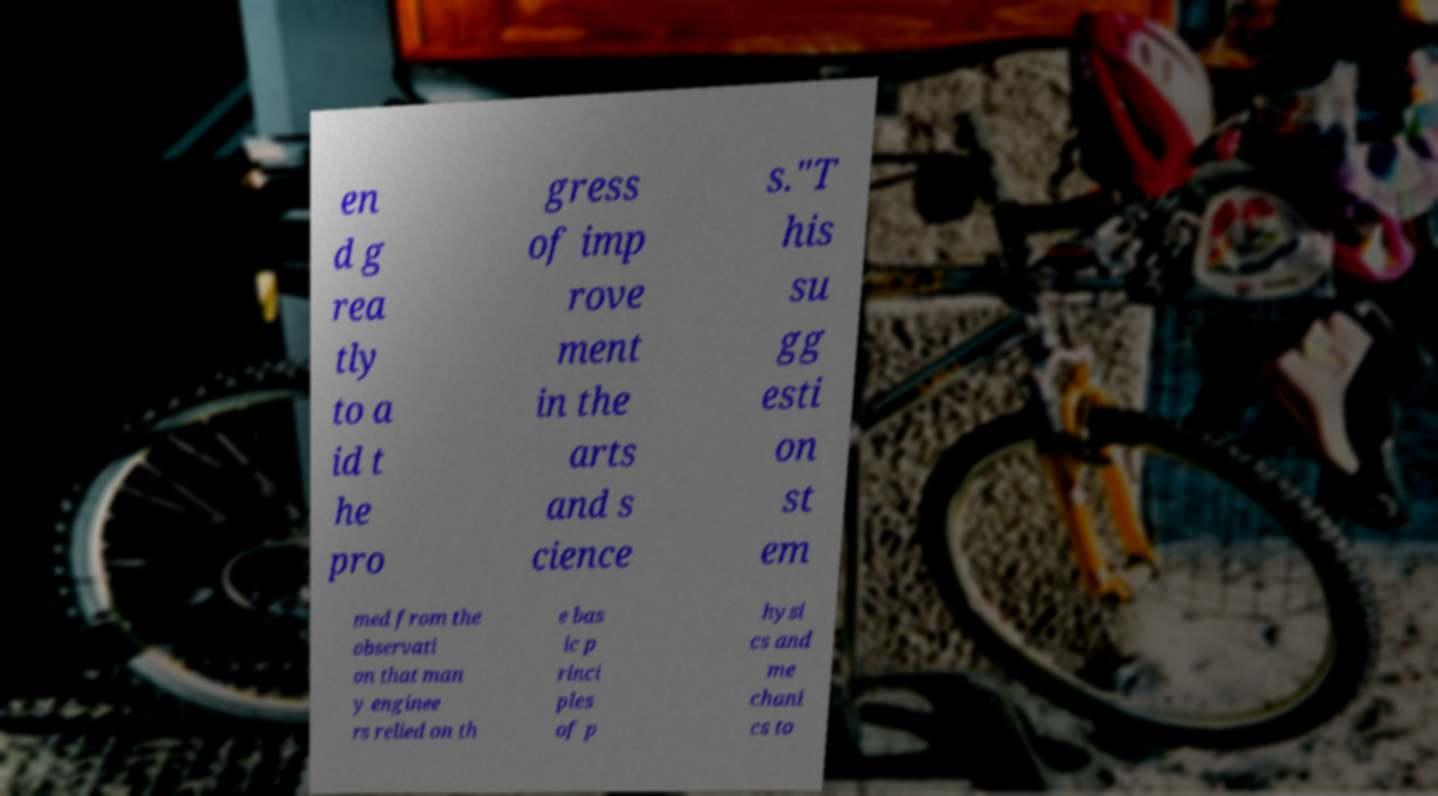Could you assist in decoding the text presented in this image and type it out clearly? en d g rea tly to a id t he pro gress of imp rove ment in the arts and s cience s."T his su gg esti on st em med from the observati on that man y enginee rs relied on th e bas ic p rinci ples of p hysi cs and me chani cs to 